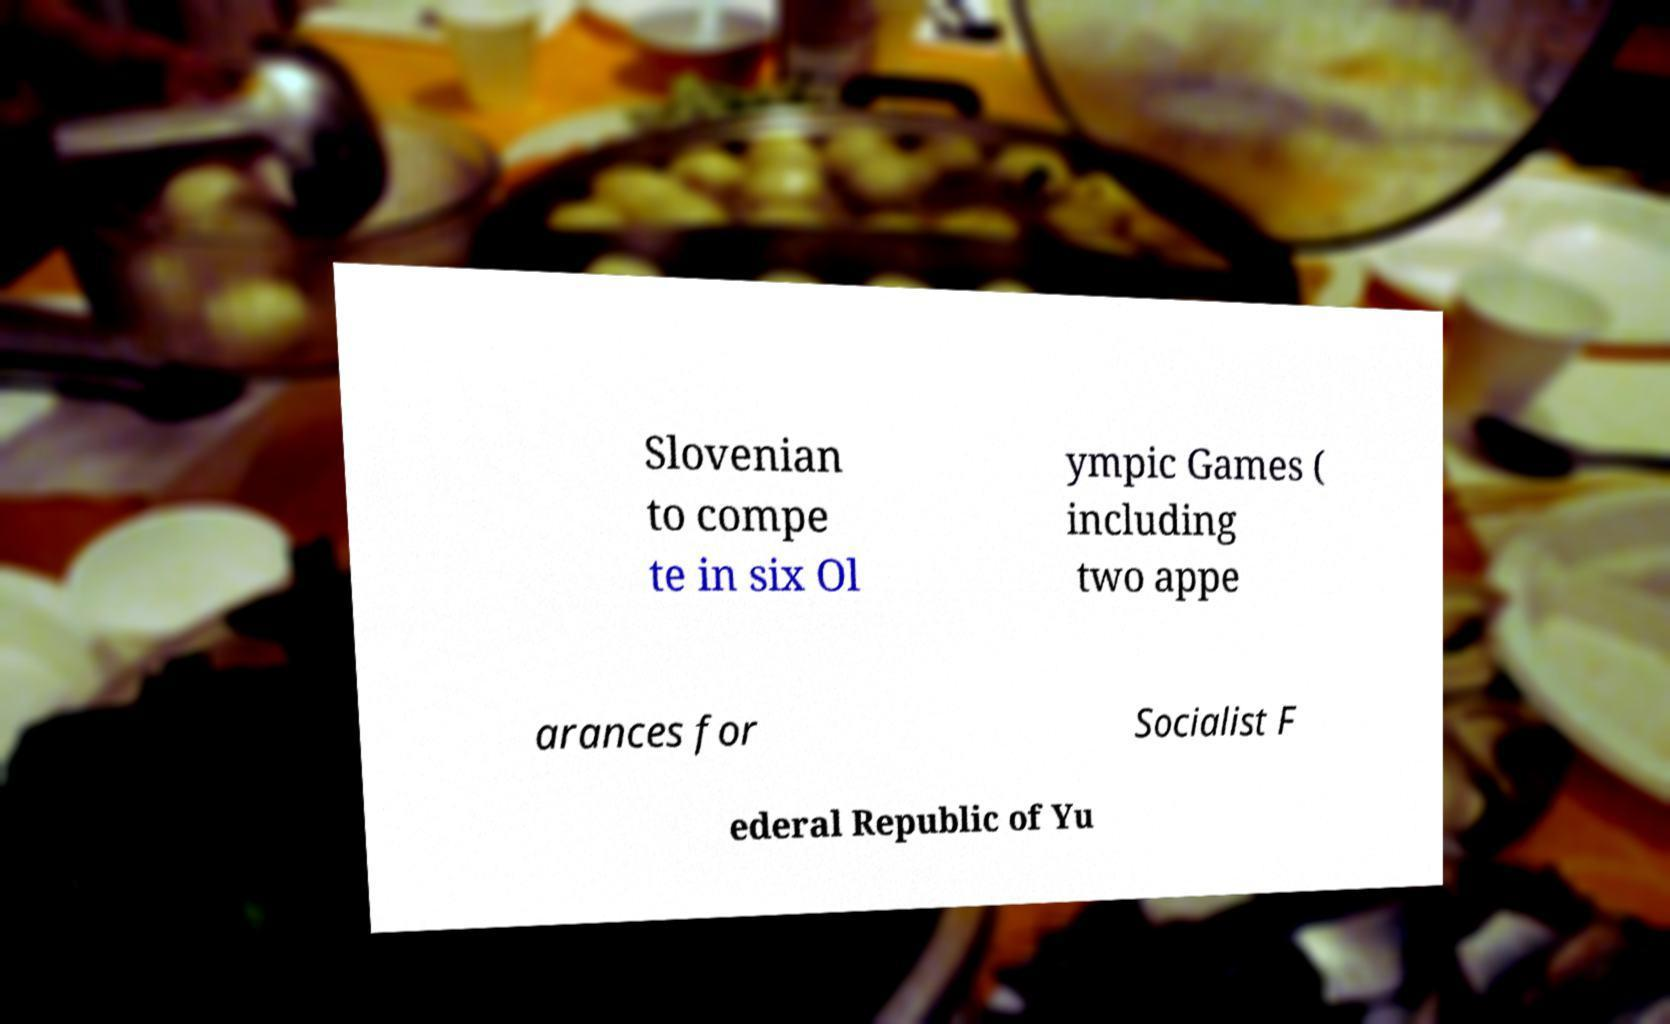Please read and relay the text visible in this image. What does it say? Slovenian to compe te in six Ol ympic Games ( including two appe arances for Socialist F ederal Republic of Yu 